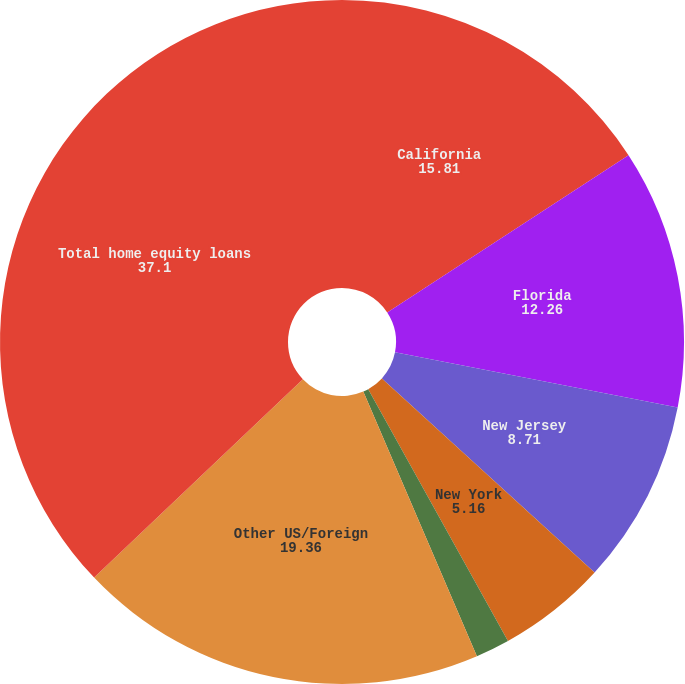Convert chart to OTSL. <chart><loc_0><loc_0><loc_500><loc_500><pie_chart><fcel>California<fcel>Florida<fcel>New Jersey<fcel>New York<fcel>Massachusetts<fcel>Other US/Foreign<fcel>Total home equity loans<nl><fcel>15.81%<fcel>12.26%<fcel>8.71%<fcel>5.16%<fcel>1.61%<fcel>19.36%<fcel>37.1%<nl></chart> 